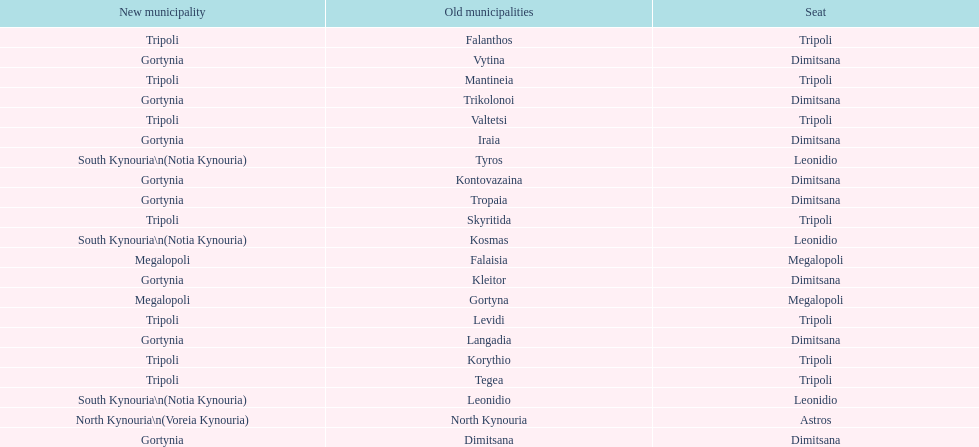What is the new municipality of tyros? South Kynouria. 